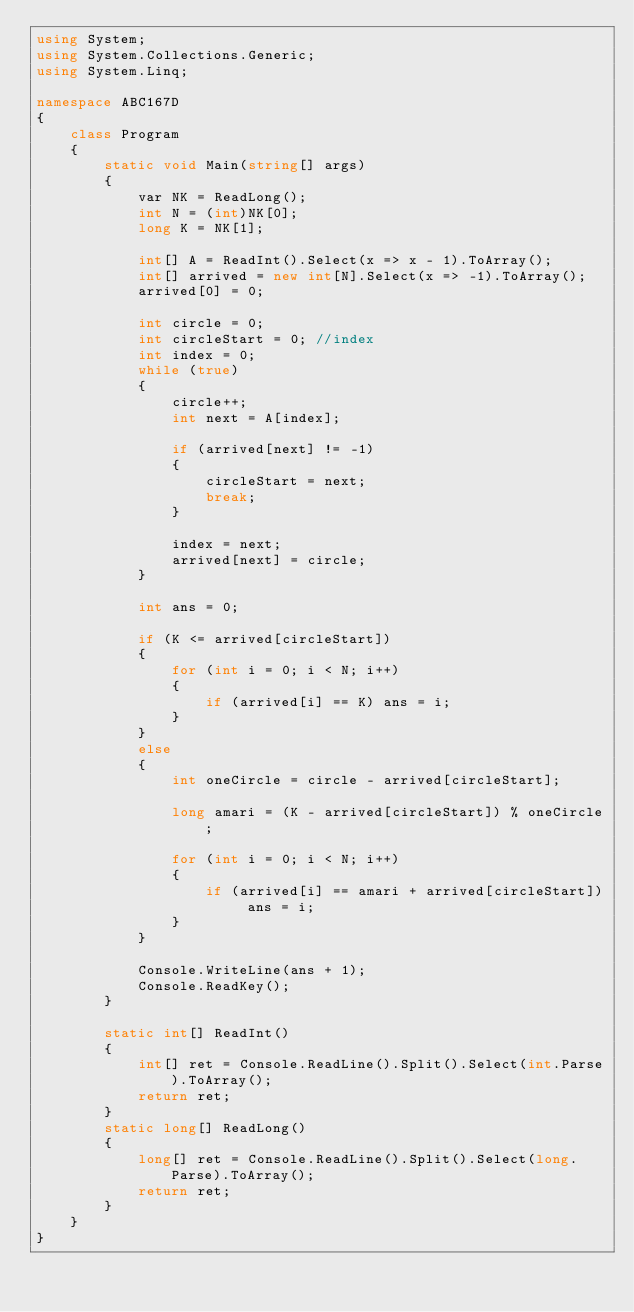Convert code to text. <code><loc_0><loc_0><loc_500><loc_500><_C#_>using System;
using System.Collections.Generic;
using System.Linq;

namespace ABC167D
{
    class Program
    {
        static void Main(string[] args)
        {
            var NK = ReadLong();
            int N = (int)NK[0];
            long K = NK[1];

            int[] A = ReadInt().Select(x => x - 1).ToArray();
            int[] arrived = new int[N].Select(x => -1).ToArray();
            arrived[0] = 0;

            int circle = 0;
            int circleStart = 0; //index
            int index = 0;
            while (true)
            {
                circle++;
                int next = A[index];

                if (arrived[next] != -1)
                {
                    circleStart = next;
                    break;
                }

                index = next;
                arrived[next] = circle;
            }

            int ans = 0;

            if (K <= arrived[circleStart])
            {
                for (int i = 0; i < N; i++)
                {
                    if (arrived[i] == K) ans = i;
                }
            }
            else
            {
                int oneCircle = circle - arrived[circleStart];

                long amari = (K - arrived[circleStart]) % oneCircle;

                for (int i = 0; i < N; i++)
                {
                    if (arrived[i] == amari + arrived[circleStart]) ans = i;
                }
            }

            Console.WriteLine(ans + 1);
            Console.ReadKey();
        }

        static int[] ReadInt()
        {
            int[] ret = Console.ReadLine().Split().Select(int.Parse).ToArray();
            return ret;
        }
        static long[] ReadLong()
        {
            long[] ret = Console.ReadLine().Split().Select(long.Parse).ToArray();
            return ret;
        }
    }
}
</code> 